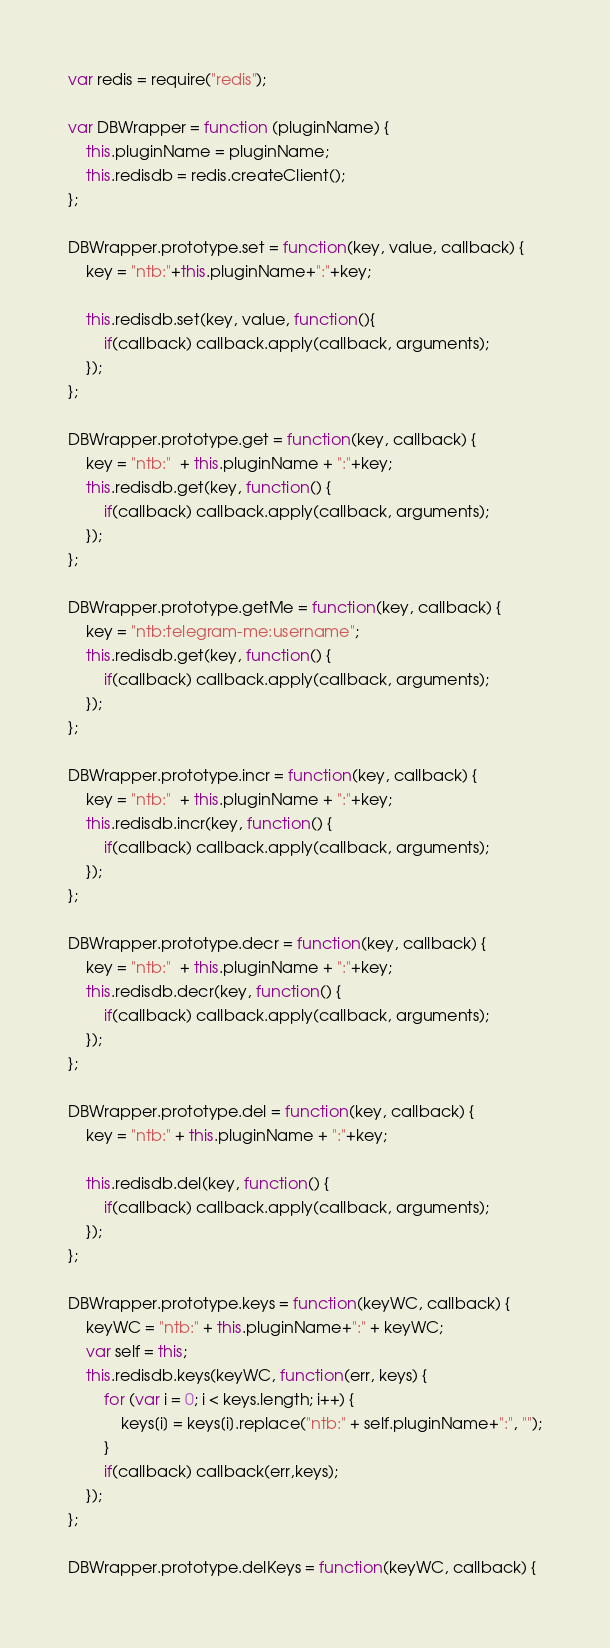Convert code to text. <code><loc_0><loc_0><loc_500><loc_500><_JavaScript_>var redis = require("redis");

var DBWrapper = function (pluginName) {
    this.pluginName = pluginName;
    this.redisdb = redis.createClient();
};

DBWrapper.prototype.set = function(key, value, callback) {
    key = "ntb:"+this.pluginName+":"+key;
    
    this.redisdb.set(key, value, function(){
        if(callback) callback.apply(callback, arguments);
    });
};

DBWrapper.prototype.get = function(key, callback) {
    key = "ntb:"  + this.pluginName + ":"+key;
    this.redisdb.get(key, function() {
        if(callback) callback.apply(callback, arguments);
    });
};

DBWrapper.prototype.getMe = function(key, callback) {
    key = "ntb:telegram-me:username";
    this.redisdb.get(key, function() {
        if(callback) callback.apply(callback, arguments);
    });
};

DBWrapper.prototype.incr = function(key, callback) {
    key = "ntb:"  + this.pluginName + ":"+key;
    this.redisdb.incr(key, function() {
        if(callback) callback.apply(callback, arguments);
    });
};

DBWrapper.prototype.decr = function(key, callback) {
    key = "ntb:"  + this.pluginName + ":"+key;
    this.redisdb.decr(key, function() {
        if(callback) callback.apply(callback, arguments);
    });
};

DBWrapper.prototype.del = function(key, callback) {
    key = "ntb:" + this.pluginName + ":"+key;

    this.redisdb.del(key, function() {
        if(callback) callback.apply(callback, arguments);
    });
};

DBWrapper.prototype.keys = function(keyWC, callback) {
    keyWC = "ntb:" + this.pluginName+":" + keyWC;
    var self = this;
    this.redisdb.keys(keyWC, function(err, keys) {
        for (var i = 0; i < keys.length; i++) {
            keys[i] = keys[i].replace("ntb:" + self.pluginName+":", "");
        }
        if(callback) callback(err,keys);
    });
};

DBWrapper.prototype.delKeys = function(keyWC, callback) {</code> 